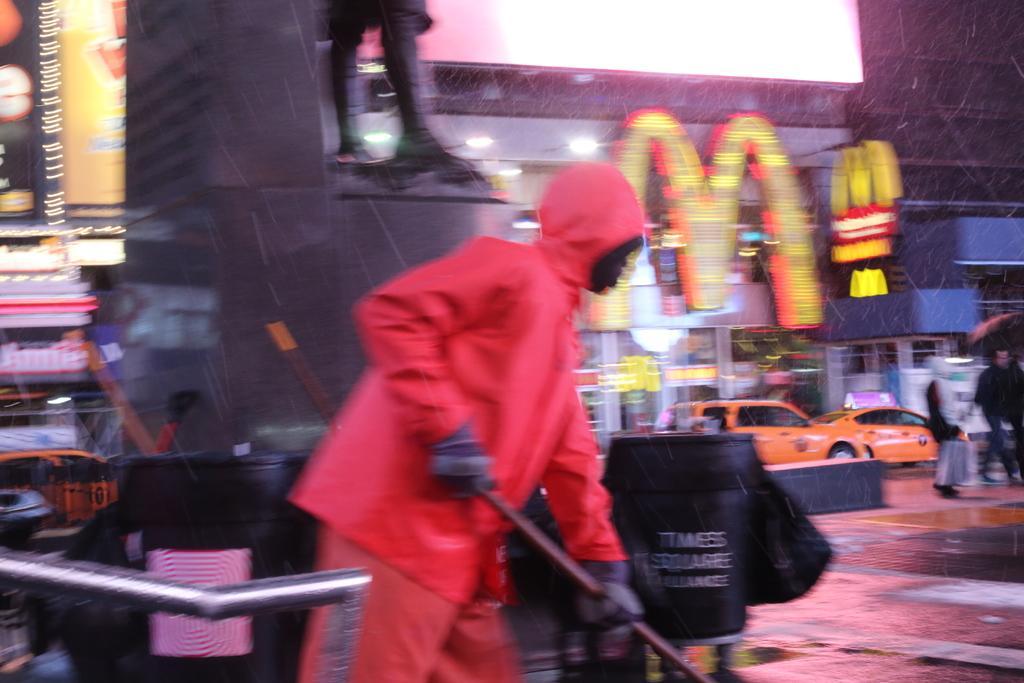Please provide a concise description of this image. This image consists of a man wearing pink dress is cleaning the road. In the background, there are buildings along with the cars. At the bottom, there is a road. 